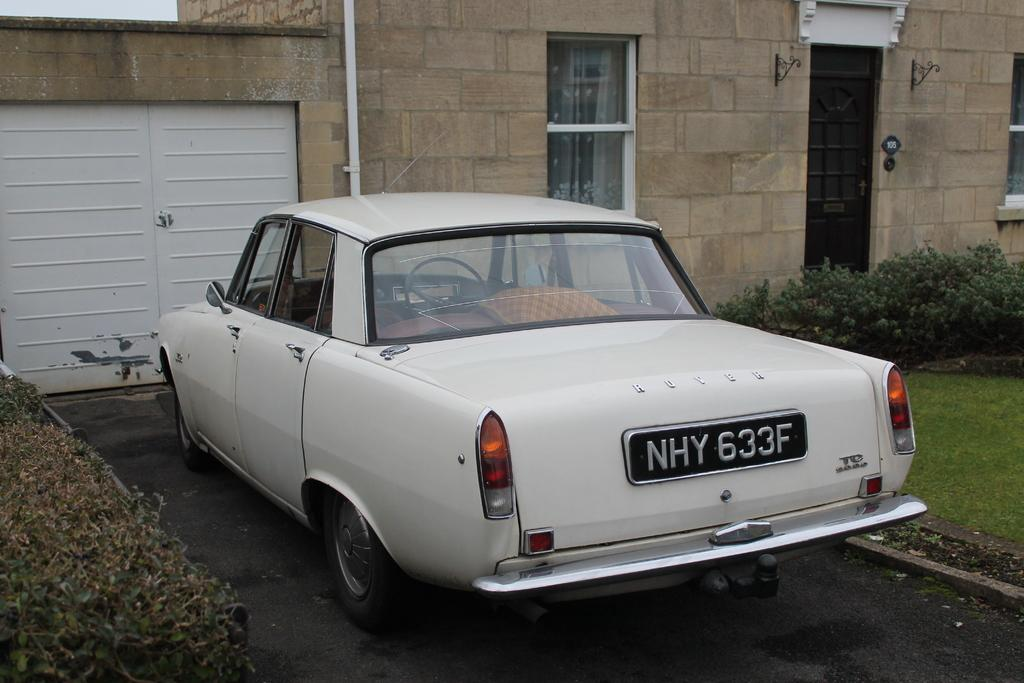What is the main subject of the image? There is a vehicle in the image. Where is the vehicle located? The vehicle is on the road. What can be seen in the background of the image? There is a building and plants in the background of the image. What type of book is the vehicle reading in the image? There is no book or reading activity present in the image; it features a vehicle on the road with a building and plants in the background. 